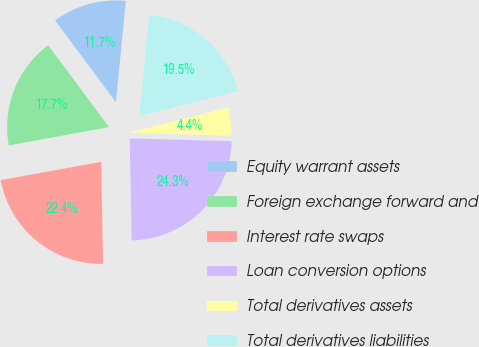Convert chart. <chart><loc_0><loc_0><loc_500><loc_500><pie_chart><fcel>Equity warrant assets<fcel>Foreign exchange forward and<fcel>Interest rate swaps<fcel>Loan conversion options<fcel>Total derivatives assets<fcel>Total derivatives liabilities<nl><fcel>11.74%<fcel>17.69%<fcel>22.44%<fcel>24.26%<fcel>4.37%<fcel>19.51%<nl></chart> 